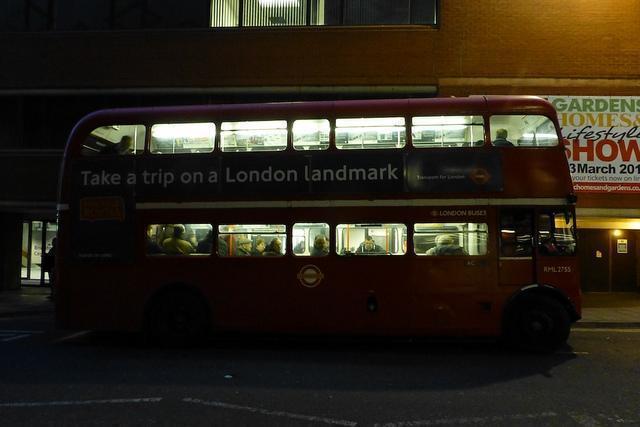Why is the light on inside the double-decker bus?
From the following set of four choices, select the accurate answer to respond to the question.
Options: Visibility, convenience, aesthetics, by law. Visibility. 